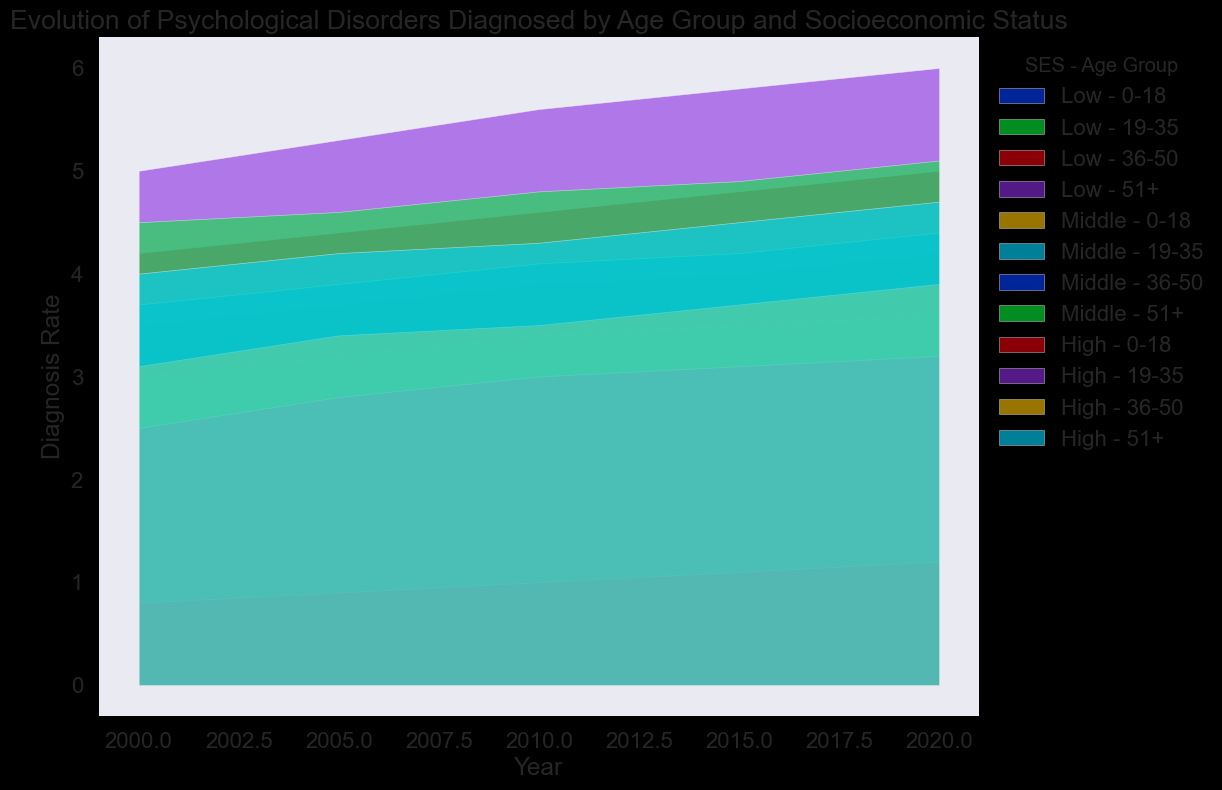What overall trend do you observe for the diagnosis rates in the 51+ age group from 2000 to 2020? Observing the area chart, the diagnosis rates for the 51+ age group consistently increase from 2000 to 2020 across all socioeconomic statuses. Specifically, the rates for low SES rise from 5.0 to 6.0, for middle SES from 4.5 to 5.1, and for high SES from 4.0 to 4.7.
Answer: Increasing trend Which socioeconomic status has the highest diagnosis rate in the year 2020 for the 19-35 age group? Referring to the year 2020 on the area chart for the 19-35 age group, the low SES has the highest diagnosis rate among the socioeconomic statuses, with a rate of 4.2 compared to 3.6 for middle SES and 3.2 for high SES.
Answer: Low SES Compare the diagnosis rates between the 0-18 age group and the 36-50 age group in 2015. Which group has higher rates and by how much? For the 0-18 age group, the diagnosis rates are 1.6 (Low SES), 1.3 (Middle SES), and 1.1 (High SES). For the 36-50 age group, the rates are 4.8 (Low SES), 4.2 (Middle SES), and 3.7 (High SES). Each rate in the 36-50 group is higher. For example, Low SES shows an extra 3.2 (4.8 - 1.6), Middle SES an extra 2.9 (4.2 - 1.3), and High SES an extra 2.6 (3.7 - 1.1).
Answer: 36-50 age group; 3.2 (Low SES), 2.9 (Middle SES), 2.6 (High SES) What visual patterns emerge for middle SES across different age groups in the year 2010? Focusing on the year 2010, the pattern reveals that the diagnosis rate increases with age. The middle SES rates are 1.2 (0-18), 3.4 (19-35), 4.1 (36-50), and 4.8 (51+), suggesting a steady increase as the age group advances.
Answer: Increasing with age How does the rate of diagnosis for high SES in the 36-50 age group change from 2000 to 2015? The chart for the high SES in the 36-50 age group shows the diagnosis rate increases from 3.1 in 2000 to 3.7 in 2015. Specifically, the rates rise from year to year: from 3.1 (2000) to 3.4 (2005), to 3.5 (2010), and finally 3.7 (2015), indicating an upward trend.
Answer: Increases by 0.6 What could be indicated by the similar pattern between high SES and middle SES in the 51+ age group over the years? Observing the patterns in the 51+ age group for high SES and middle SES, both groups show a parallel upward trend in diagnosis rates from 2000 to 2020. This similarity may indicate that the increase in diagnosis rates affects both socioeconomic statuses similarly within this age group, pointing to a potentially common underlying factor.
Answer: Parallel upward trend 